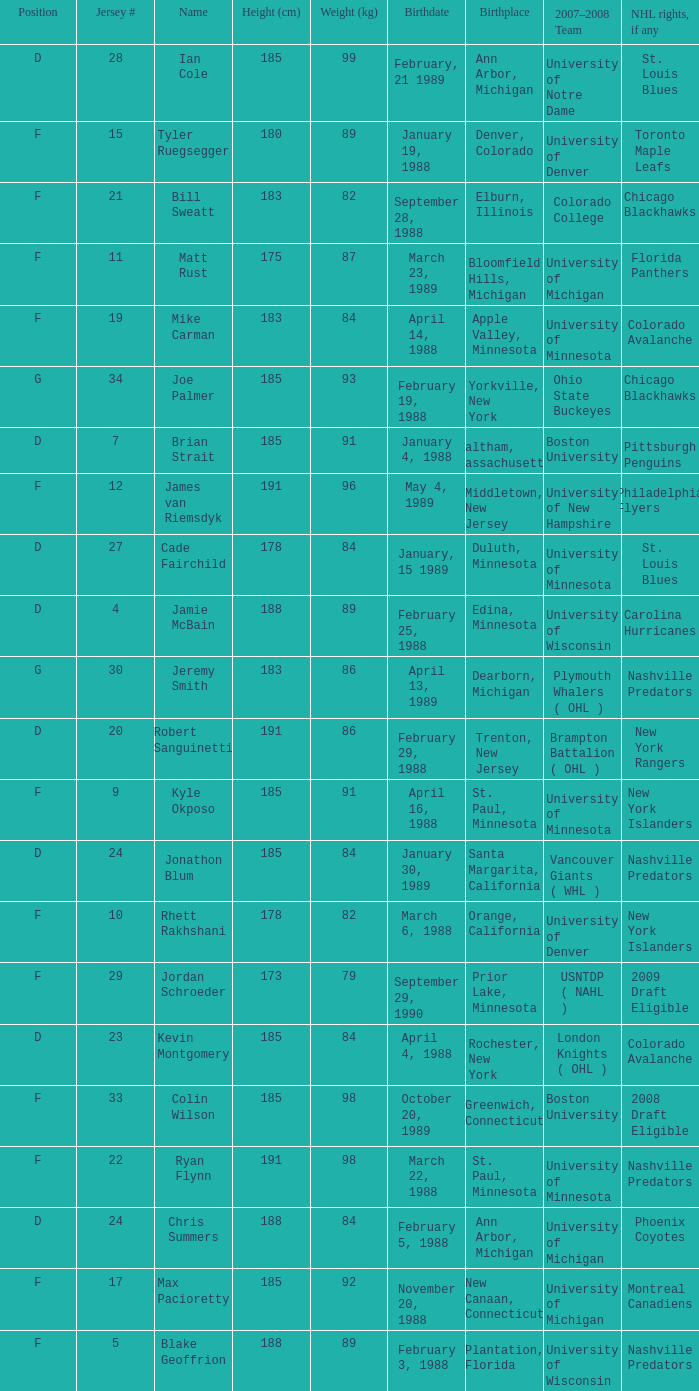Which Height (cm) has a Birthplace of new canaan, connecticut? 1.0. 